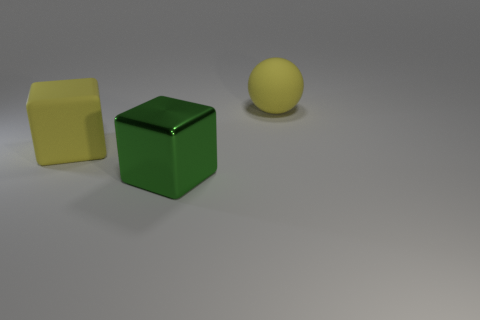What could be the purpose of the objects in this image? These objects might serve several purposes. Given their basic shapes and contrasting colors, they could be part of a teaching tool or toys designed for educational activities, aiding in learning about shapes, colors, and sizes. Additionally, they might also be used in a visual arts context, perhaps in a still life composition for a study in shading, lighting, and perspective. 